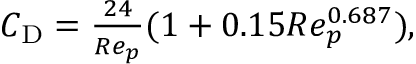Convert formula to latex. <formula><loc_0><loc_0><loc_500><loc_500>\begin{array} { r } { C _ { D } = \frac { 2 4 } { R e _ { p } } ( 1 + 0 { . } 1 5 R e _ { p } ^ { 0 { . } 6 8 7 } ) , } \end{array}</formula> 